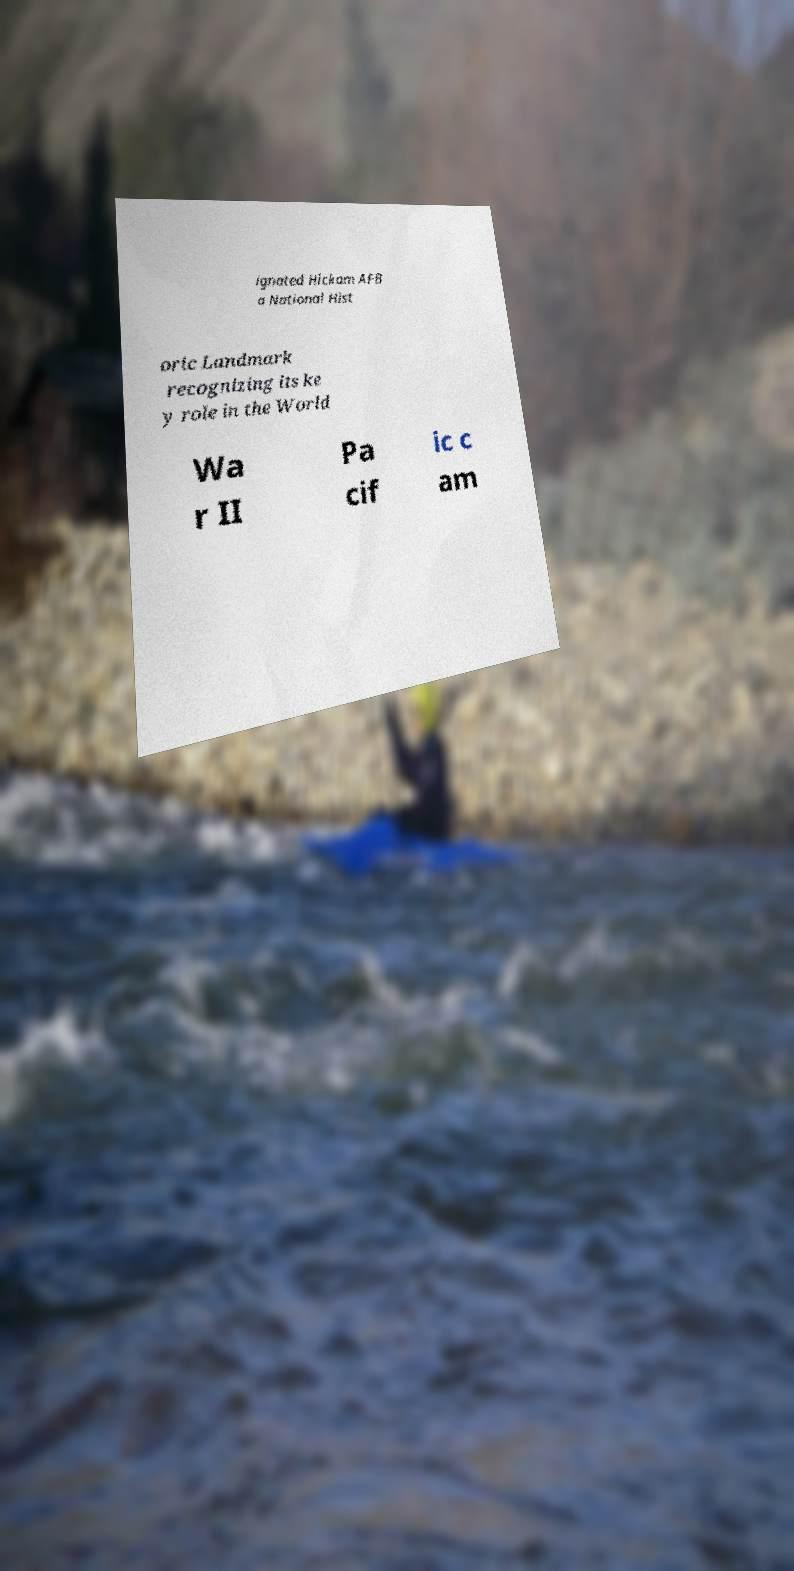Could you assist in decoding the text presented in this image and type it out clearly? ignated Hickam AFB a National Hist oric Landmark recognizing its ke y role in the World Wa r II Pa cif ic c am 